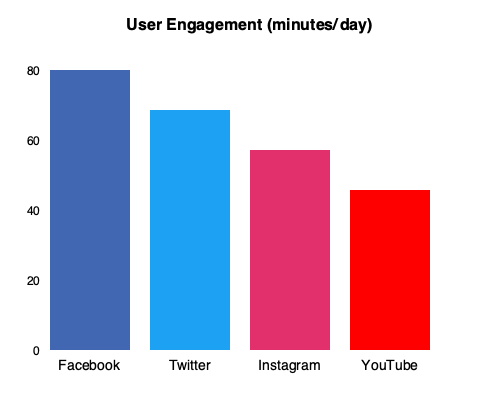As a senior editor looking to collaborate on a social media strategy, which two platforms would you recommend focusing on based on their combined user engagement time, and what is the total engagement time for these platforms? To answer this question, we need to follow these steps:

1. Identify the user engagement time for each platform:
   - Facebook: 70 minutes/day
   - Twitter: 60 minutes/day
   - Instagram: 50 minutes/day
   - YouTube: 40 minutes/day

2. Determine the two platforms with the highest engagement:
   Facebook (70 minutes) and Twitter (60 minutes) have the highest engagement times.

3. Calculate the combined engagement time:
   Facebook + Twitter = 70 + 60 = 130 minutes/day

By focusing on Facebook and Twitter, we can maximize our reach to users who spend the most time on social media platforms. This strategy allows for greater potential engagement and collaboration opportunities with our audience.

As a senior editor valuing collaboration, this data-driven approach provides a solid foundation for team discussions and strategy development. It's important to note that while these two platforms offer the highest combined engagement time, the team should also consider factors such as target audience demographics and content type when finalizing the social media strategy.
Answer: Facebook and Twitter; 130 minutes/day 